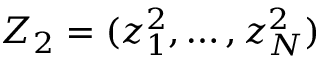Convert formula to latex. <formula><loc_0><loc_0><loc_500><loc_500>Z _ { 2 } = ( z _ { 1 } ^ { 2 } , \dots , z _ { N } ^ { 2 } )</formula> 